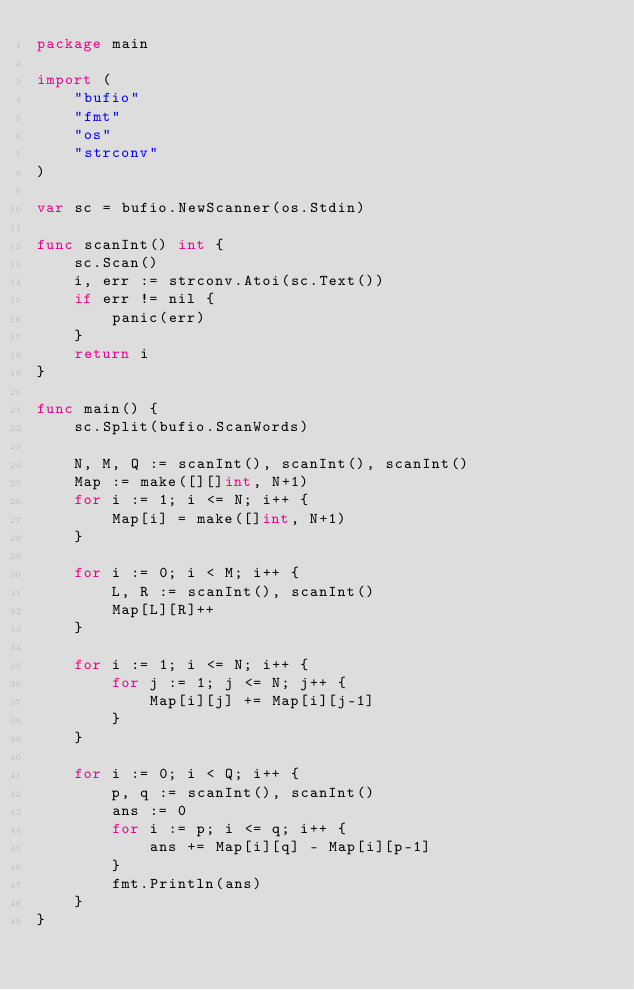<code> <loc_0><loc_0><loc_500><loc_500><_Go_>package main

import (
	"bufio"
	"fmt"
	"os"
	"strconv"
)

var sc = bufio.NewScanner(os.Stdin)

func scanInt() int {
	sc.Scan()
	i, err := strconv.Atoi(sc.Text())
	if err != nil {
		panic(err)
	}
	return i
}

func main() {
	sc.Split(bufio.ScanWords)

	N, M, Q := scanInt(), scanInt(), scanInt()
	Map := make([][]int, N+1)
	for i := 1; i <= N; i++ {
		Map[i] = make([]int, N+1)
	}

	for i := 0; i < M; i++ {
		L, R := scanInt(), scanInt()
		Map[L][R]++
	}

	for i := 1; i <= N; i++ {
		for j := 1; j <= N; j++ {
			Map[i][j] += Map[i][j-1]
		}
	}

	for i := 0; i < Q; i++ {
		p, q := scanInt(), scanInt()
		ans := 0
		for i := p; i <= q; i++ {
			ans += Map[i][q] - Map[i][p-1]
		}
		fmt.Println(ans)
	}
}
</code> 